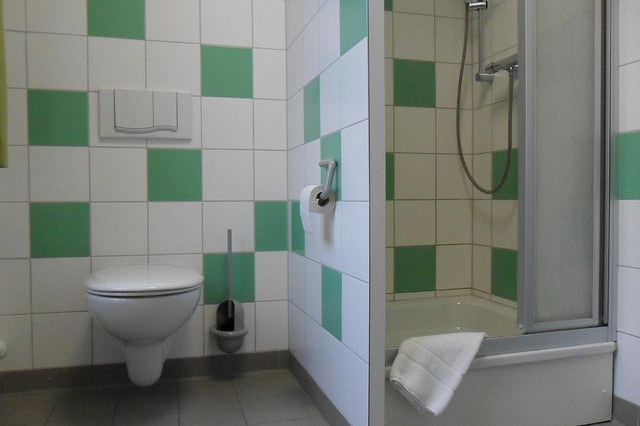Describe the objects in this image and their specific colors. I can see a toilet in olive, gray, darkgray, and black tones in this image. 